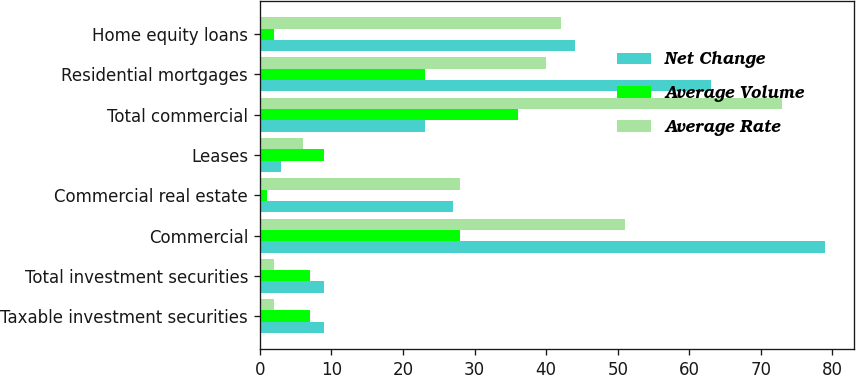<chart> <loc_0><loc_0><loc_500><loc_500><stacked_bar_chart><ecel><fcel>Taxable investment securities<fcel>Total investment securities<fcel>Commercial<fcel>Commercial real estate<fcel>Leases<fcel>Total commercial<fcel>Residential mortgages<fcel>Home equity loans<nl><fcel>Net Change<fcel>9<fcel>9<fcel>79<fcel>27<fcel>3<fcel>23<fcel>63<fcel>44<nl><fcel>Average Volume<fcel>7<fcel>7<fcel>28<fcel>1<fcel>9<fcel>36<fcel>23<fcel>2<nl><fcel>Average Rate<fcel>2<fcel>2<fcel>51<fcel>28<fcel>6<fcel>73<fcel>40<fcel>42<nl></chart> 